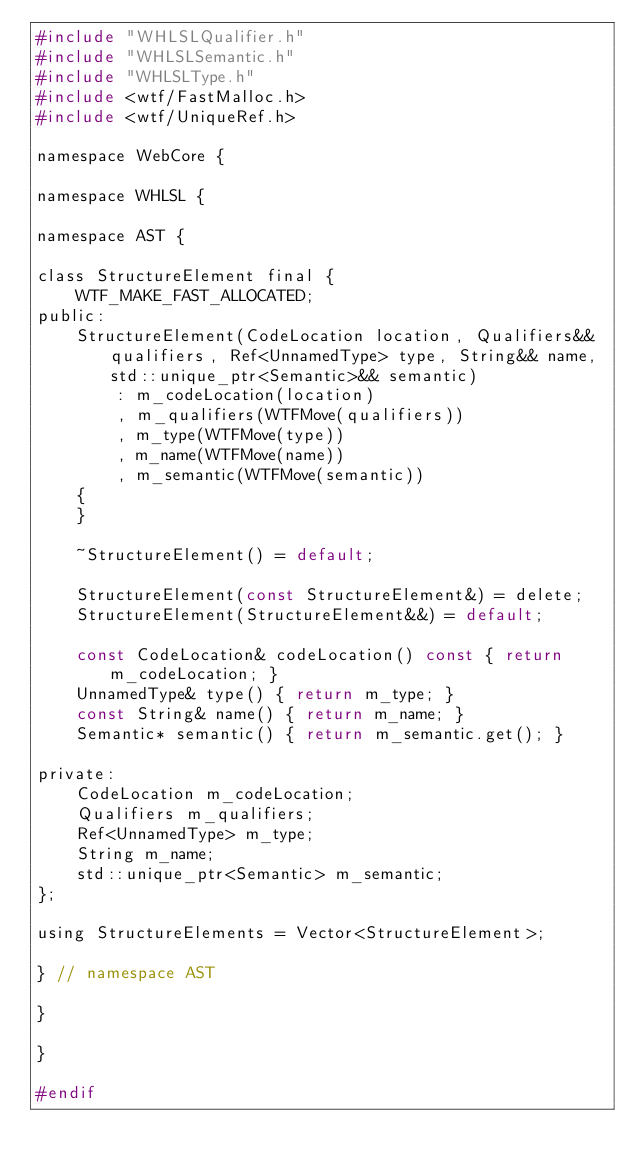Convert code to text. <code><loc_0><loc_0><loc_500><loc_500><_C_>#include "WHLSLQualifier.h"
#include "WHLSLSemantic.h"
#include "WHLSLType.h"
#include <wtf/FastMalloc.h>
#include <wtf/UniqueRef.h>

namespace WebCore {

namespace WHLSL {

namespace AST {

class StructureElement final {
    WTF_MAKE_FAST_ALLOCATED;
public:
    StructureElement(CodeLocation location, Qualifiers&& qualifiers, Ref<UnnamedType> type, String&& name, std::unique_ptr<Semantic>&& semantic)
        : m_codeLocation(location)
        , m_qualifiers(WTFMove(qualifiers))
        , m_type(WTFMove(type))
        , m_name(WTFMove(name))
        , m_semantic(WTFMove(semantic))
    {
    }

    ~StructureElement() = default;

    StructureElement(const StructureElement&) = delete;
    StructureElement(StructureElement&&) = default;

    const CodeLocation& codeLocation() const { return m_codeLocation; }
    UnnamedType& type() { return m_type; }
    const String& name() { return m_name; }
    Semantic* semantic() { return m_semantic.get(); }

private:
    CodeLocation m_codeLocation;
    Qualifiers m_qualifiers;
    Ref<UnnamedType> m_type;
    String m_name;
    std::unique_ptr<Semantic> m_semantic;
};

using StructureElements = Vector<StructureElement>;

} // namespace AST

}

}

#endif
</code> 